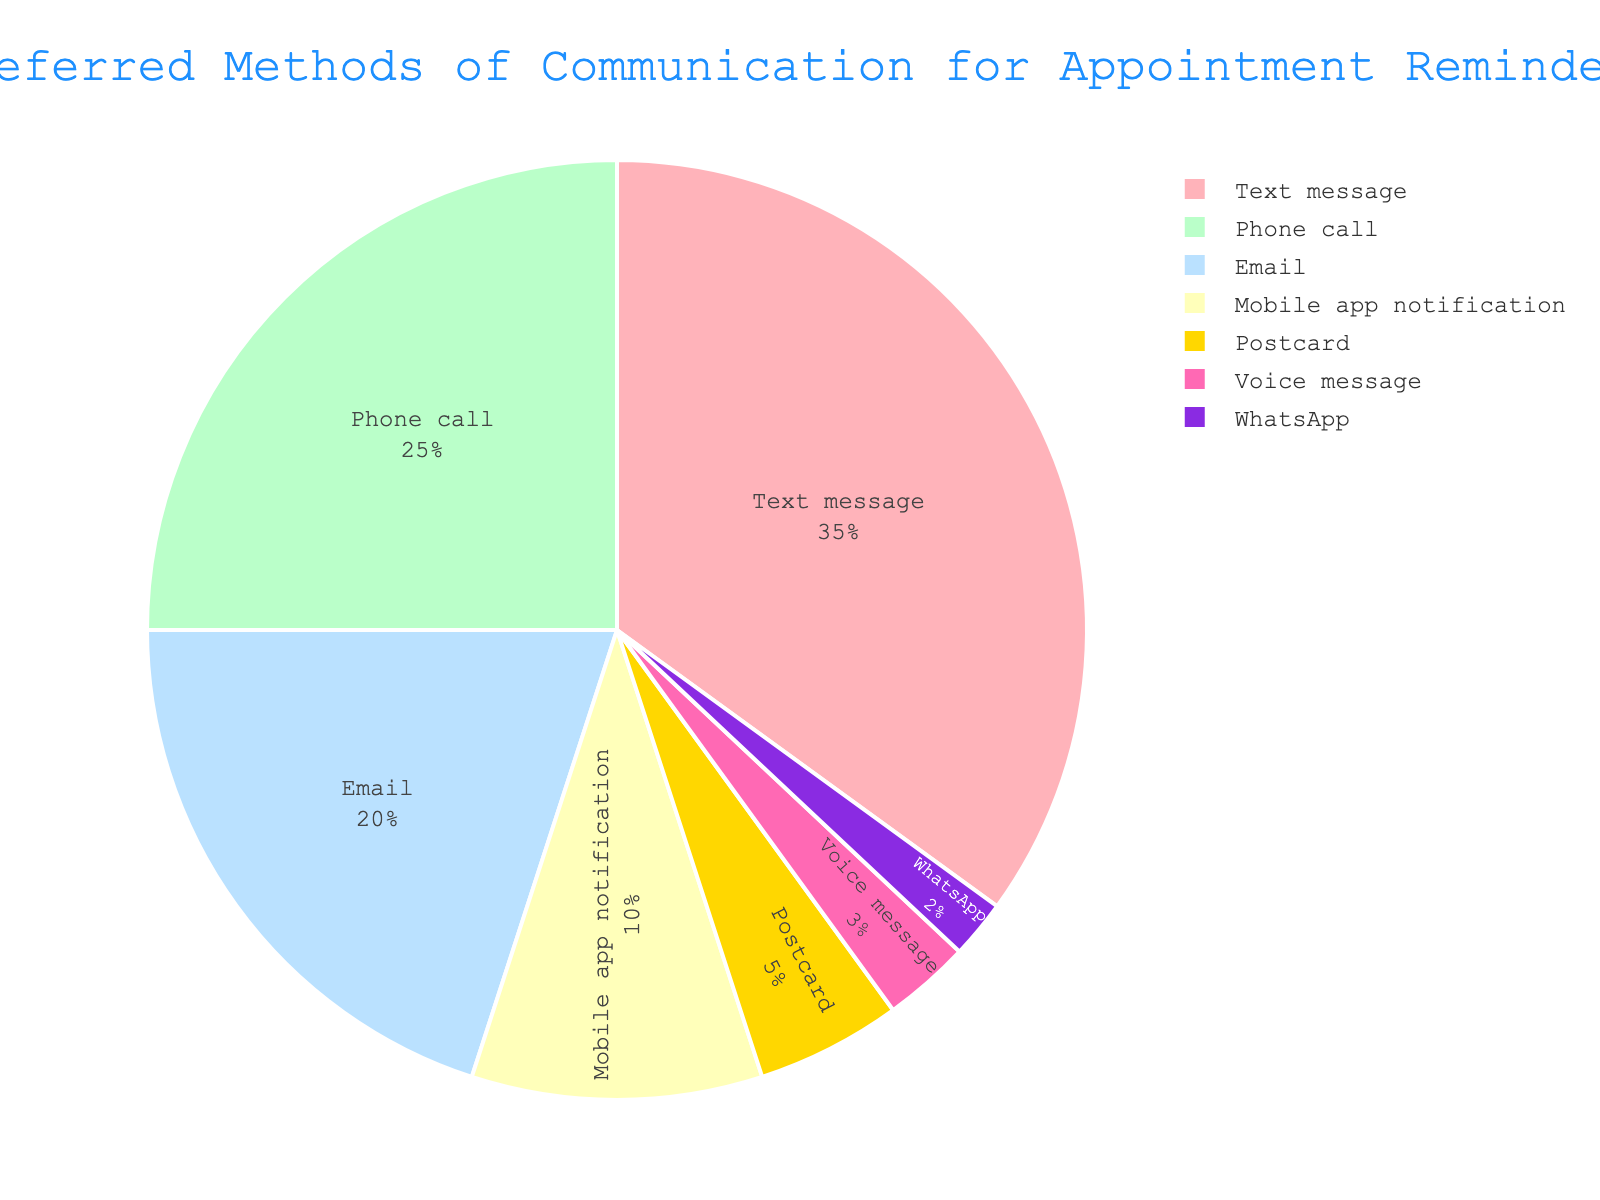How many more people prefer Text message over Email for appointment reminders? Text message has a percentage of 35% and Email has a percentage of 20%. Subtracting Email from Text message (35 - 20), we get 15%.
Answer: 15% Which method is less preferred: Mobile app notification or Postcard? Mobile app notification has a percentage of 10% and Postcard has a percentage of 5%. Since 5% is less than 10%, Postcard is less preferred.
Answer: Postcard What methods combined make up more than half of the total preferences? Text message (35%), Phone call (25%), Email (20%) combined make up 80%, which is more than half of the total.
Answer: Text message, Phone call, and Email What is the percentage of people who prefer visual methods like Mobile app notification over the traditional method like Postcard? Mobile app notification has 10% and Postcard has 5%. Subtracting Postcard from Mobile app notification (10 - 5), we get 5%.
Answer: 5% Compare the combined percentage of Text message and Email to Phone call and Mobile app notification. Which pair is higher? Text message and Email combined percentage is 35 + 20 = 55%. Phone call and Mobile app notification combined percentage is 25 + 10 = 35%. Since 55% is greater than 35%, Text message and Email are higher.
Answer: Text message and Email Is the percentage of people who prefer WhatsApp and Voice message combined greater than the percentage of people who prefer Postcard? WhatsApp has 2% and Voice message has 3%, combined they make 5%. Postcard has 5%. Since 5% is equal to 5%, they are the same.
Answer: No Which method has the highest preference for appointment reminders? The method with the highest percentage is Text message with 35%.
Answer: Text message What is the difference in preference percentage between the most and least preferred methods? The most preferred is Text message with 35% and the least preferred is WhatsApp with 2%. Subtracting WhatsApp from Text message (35 - 2), we get 33%.
Answer: 33% What visual color corresponds to the Email communication method in the chart? The Email method corresponds to the light blue color in the pie chart.
Answer: Light blue 